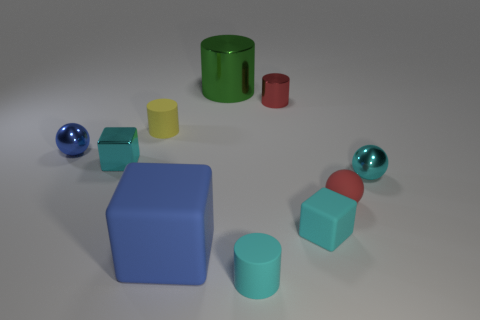Subtract all balls. How many objects are left? 7 Add 5 large cylinders. How many large cylinders exist? 6 Subtract 0 yellow spheres. How many objects are left? 10 Subtract all purple matte cylinders. Subtract all tiny cyan matte objects. How many objects are left? 8 Add 1 cyan shiny spheres. How many cyan shiny spheres are left? 2 